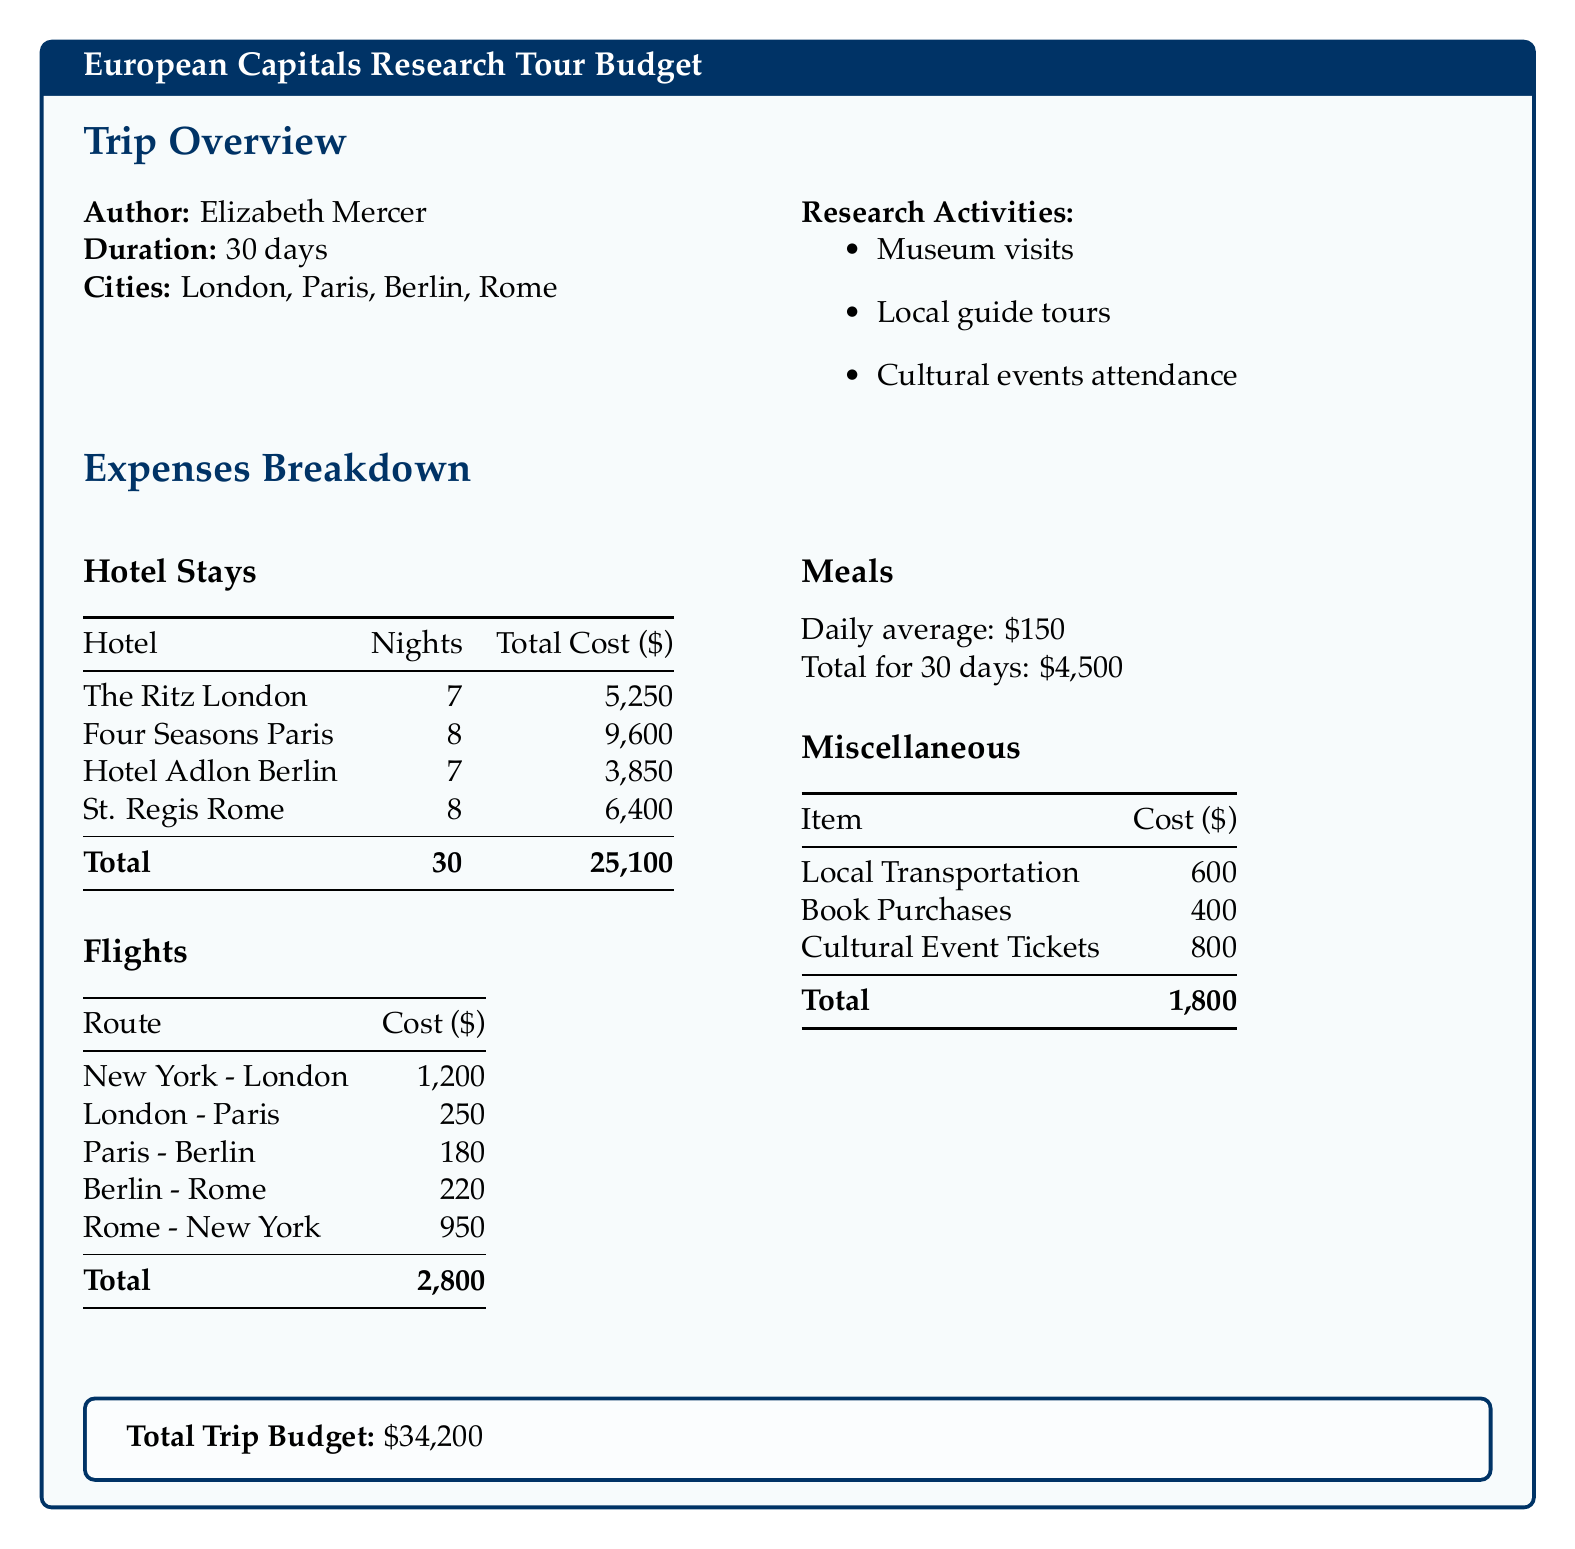What is the total cost for hotel stays? The total cost for hotel stays is provided in the hotel stays section of the document, which sums up to $25,100.
Answer: $25,100 How many cities were visited during the trip? The number of cities visited can be found in the trip overview section, which lists four cities.
Answer: 4 What was the daily average meal cost? The daily average meal cost is stated in the meals section of the document, which is $150.
Answer: $150 What was the total cost of flights? The total cost of flights is summarized at the end of the flights section, totaling $2,800.
Answer: $2,800 What is the total trip budget? The total trip budget is highlighted in the summary box at the end of the document, amounting to $34,200.
Answer: $34,200 How many nights did the author stay at the Four Seasons Paris? The number of nights at the Four Seasons Paris is specified in the hotel stays table, which shows 8 nights.
Answer: 8 What was the cost for local transportation? The cost for local transportation is listed under miscellaneous expenses, which is $600.
Answer: $600 What is the combined cost of cultural event tickets and book purchases? The combined cost can be calculated by adding the costs in the miscellaneous section, which totals to $1,200 ($800 + $400).
Answer: $1,200 